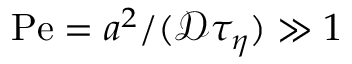Convert formula to latex. <formula><loc_0><loc_0><loc_500><loc_500>P e = a ^ { 2 } / ( \ m a t h s c r { D } \tau _ { \eta } ) \gg 1</formula> 